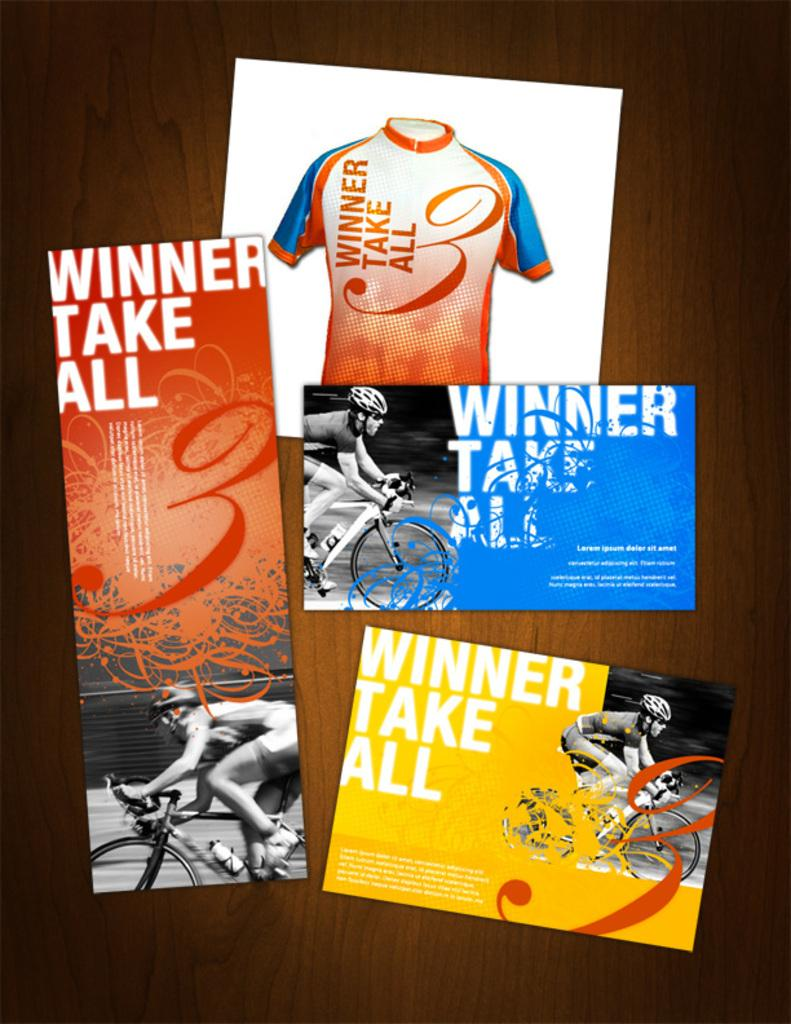<image>
Create a compact narrative representing the image presented. Several different posters all claiming that the winner takes it all. 